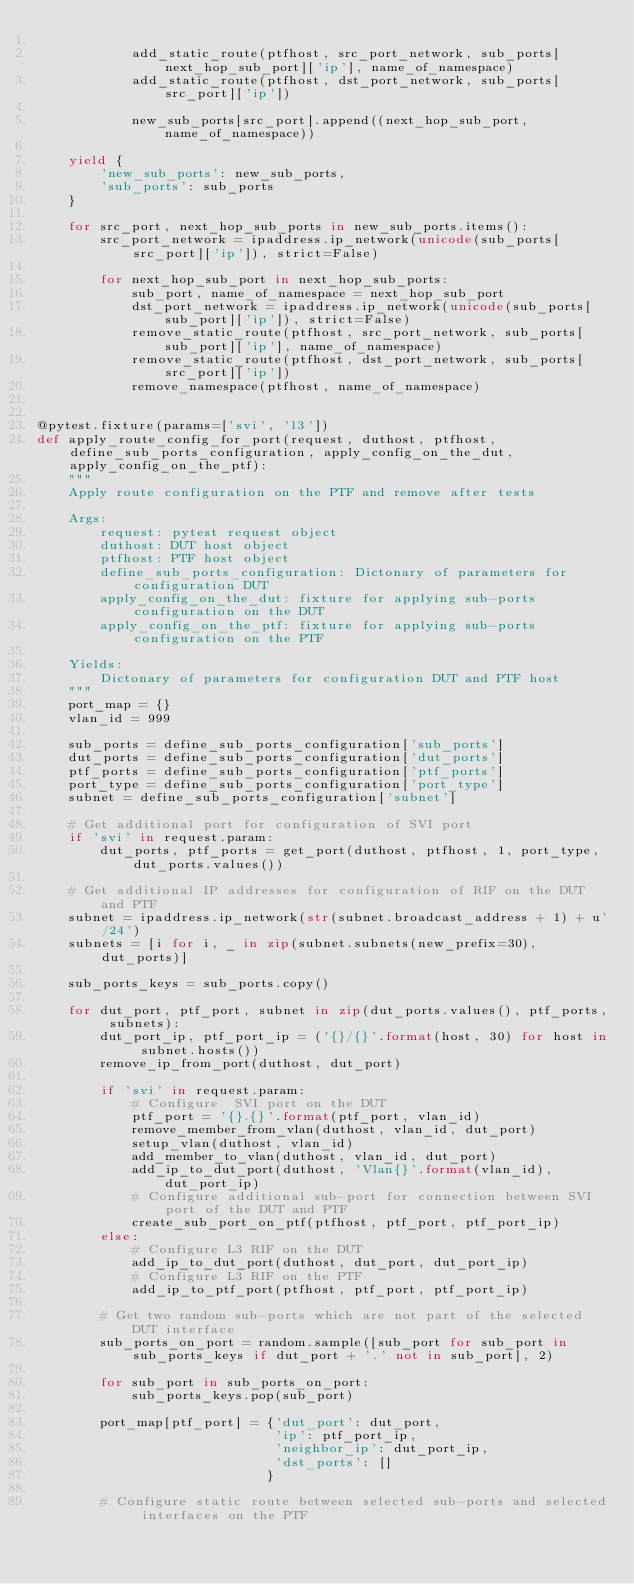<code> <loc_0><loc_0><loc_500><loc_500><_Python_>
            add_static_route(ptfhost, src_port_network, sub_ports[next_hop_sub_port]['ip'], name_of_namespace)
            add_static_route(ptfhost, dst_port_network, sub_ports[src_port]['ip'])

            new_sub_ports[src_port].append((next_hop_sub_port, name_of_namespace))

    yield {
        'new_sub_ports': new_sub_ports,
        'sub_ports': sub_ports
    }

    for src_port, next_hop_sub_ports in new_sub_ports.items():
        src_port_network = ipaddress.ip_network(unicode(sub_ports[src_port]['ip']), strict=False)

        for next_hop_sub_port in next_hop_sub_ports:
            sub_port, name_of_namespace = next_hop_sub_port
            dst_port_network = ipaddress.ip_network(unicode(sub_ports[sub_port]['ip']), strict=False)
            remove_static_route(ptfhost, src_port_network, sub_ports[sub_port]['ip'], name_of_namespace)
            remove_static_route(ptfhost, dst_port_network, sub_ports[src_port]['ip'])
            remove_namespace(ptfhost, name_of_namespace)


@pytest.fixture(params=['svi', 'l3'])
def apply_route_config_for_port(request, duthost, ptfhost, define_sub_ports_configuration, apply_config_on_the_dut, apply_config_on_the_ptf):
    """
    Apply route configuration on the PTF and remove after tests

    Args:
        request: pytest request object
        duthost: DUT host object
        ptfhost: PTF host object
        define_sub_ports_configuration: Dictonary of parameters for configuration DUT
        apply_config_on_the_dut: fixture for applying sub-ports configuration on the DUT
        apply_config_on_the_ptf: fixture for applying sub-ports configuration on the PTF

    Yields:
        Dictonary of parameters for configuration DUT and PTF host
    """
    port_map = {}
    vlan_id = 999

    sub_ports = define_sub_ports_configuration['sub_ports']
    dut_ports = define_sub_ports_configuration['dut_ports']
    ptf_ports = define_sub_ports_configuration['ptf_ports']
    port_type = define_sub_ports_configuration['port_type']
    subnet = define_sub_ports_configuration['subnet']

    # Get additional port for configuration of SVI port
    if 'svi' in request.param:
        dut_ports, ptf_ports = get_port(duthost, ptfhost, 1, port_type, dut_ports.values())

    # Get additional IP addresses for configuration of RIF on the DUT and PTF
    subnet = ipaddress.ip_network(str(subnet.broadcast_address + 1) + u'/24')
    subnets = [i for i, _ in zip(subnet.subnets(new_prefix=30), dut_ports)]

    sub_ports_keys = sub_ports.copy()

    for dut_port, ptf_port, subnet in zip(dut_ports.values(), ptf_ports, subnets):
        dut_port_ip, ptf_port_ip = ('{}/{}'.format(host, 30) for host in subnet.hosts())
        remove_ip_from_port(duthost, dut_port)

        if 'svi' in request.param:
            # Configure  SVI port on the DUT
            ptf_port = '{}.{}'.format(ptf_port, vlan_id)
            remove_member_from_vlan(duthost, vlan_id, dut_port)
            setup_vlan(duthost, vlan_id)
            add_member_to_vlan(duthost, vlan_id, dut_port)
            add_ip_to_dut_port(duthost, 'Vlan{}'.format(vlan_id), dut_port_ip)
            # Configure additional sub-port for connection between SVI port of the DUT and PTF
            create_sub_port_on_ptf(ptfhost, ptf_port, ptf_port_ip)
        else:
            # Configure L3 RIF on the DUT
            add_ip_to_dut_port(duthost, dut_port, dut_port_ip)
            # Configure L3 RIF on the PTF
            add_ip_to_ptf_port(ptfhost, ptf_port, ptf_port_ip)

        # Get two random sub-ports which are not part of the selected DUT interface
        sub_ports_on_port = random.sample([sub_port for sub_port in sub_ports_keys if dut_port + '.' not in sub_port], 2)

        for sub_port in sub_ports_on_port:
            sub_ports_keys.pop(sub_port)

        port_map[ptf_port] = {'dut_port': dut_port,
                              'ip': ptf_port_ip,
                              'neighbor_ip': dut_port_ip,
                              'dst_ports': []
                             }

        # Configure static route between selected sub-ports and selected interfaces on the PTF</code> 